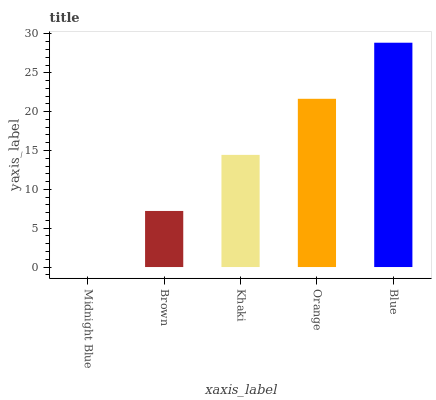Is Midnight Blue the minimum?
Answer yes or no. Yes. Is Blue the maximum?
Answer yes or no. Yes. Is Brown the minimum?
Answer yes or no. No. Is Brown the maximum?
Answer yes or no. No. Is Brown greater than Midnight Blue?
Answer yes or no. Yes. Is Midnight Blue less than Brown?
Answer yes or no. Yes. Is Midnight Blue greater than Brown?
Answer yes or no. No. Is Brown less than Midnight Blue?
Answer yes or no. No. Is Khaki the high median?
Answer yes or no. Yes. Is Khaki the low median?
Answer yes or no. Yes. Is Midnight Blue the high median?
Answer yes or no. No. Is Midnight Blue the low median?
Answer yes or no. No. 